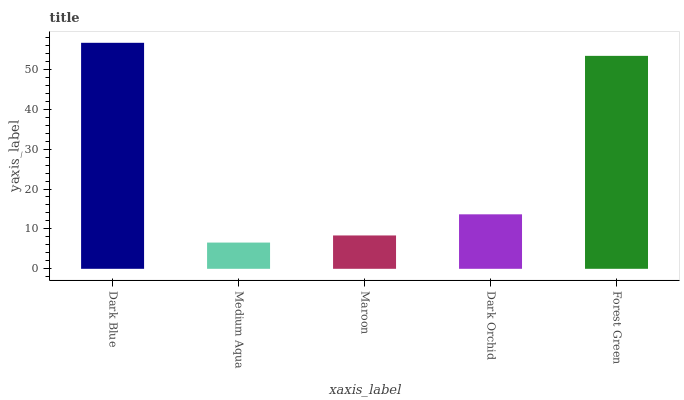Is Maroon the minimum?
Answer yes or no. No. Is Maroon the maximum?
Answer yes or no. No. Is Maroon greater than Medium Aqua?
Answer yes or no. Yes. Is Medium Aqua less than Maroon?
Answer yes or no. Yes. Is Medium Aqua greater than Maroon?
Answer yes or no. No. Is Maroon less than Medium Aqua?
Answer yes or no. No. Is Dark Orchid the high median?
Answer yes or no. Yes. Is Dark Orchid the low median?
Answer yes or no. Yes. Is Maroon the high median?
Answer yes or no. No. Is Forest Green the low median?
Answer yes or no. No. 